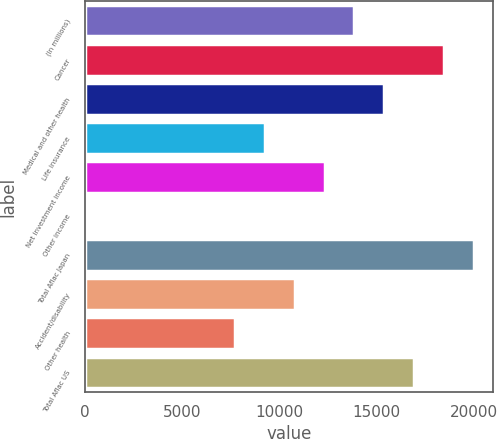Convert chart. <chart><loc_0><loc_0><loc_500><loc_500><bar_chart><fcel>(In millions)<fcel>Cancer<fcel>Medical and other health<fcel>Life insurance<fcel>Net investment income<fcel>Other income<fcel>Total Aflac Japan<fcel>Accident/disability<fcel>Other health<fcel>Total Aflac US<nl><fcel>13856.4<fcel>18466.2<fcel>15393<fcel>9246.6<fcel>12319.8<fcel>27<fcel>20002.8<fcel>10783.2<fcel>7710<fcel>16929.6<nl></chart> 